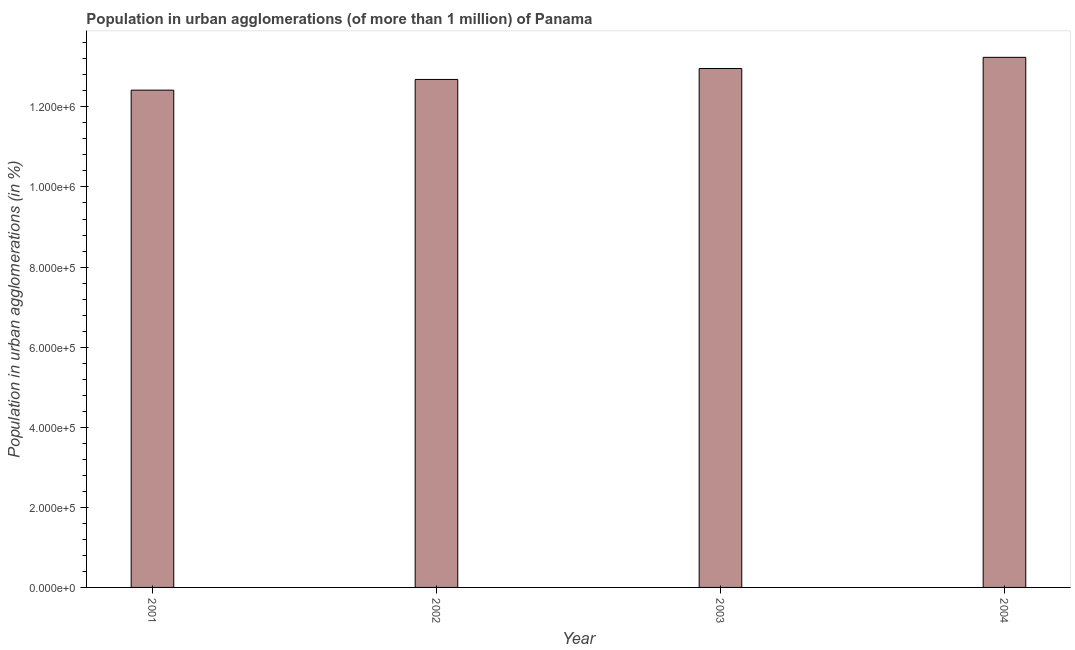What is the title of the graph?
Provide a succinct answer. Population in urban agglomerations (of more than 1 million) of Panama. What is the label or title of the Y-axis?
Keep it short and to the point. Population in urban agglomerations (in %). What is the population in urban agglomerations in 2003?
Provide a short and direct response. 1.30e+06. Across all years, what is the maximum population in urban agglomerations?
Your response must be concise. 1.32e+06. Across all years, what is the minimum population in urban agglomerations?
Provide a short and direct response. 1.24e+06. In which year was the population in urban agglomerations maximum?
Your answer should be very brief. 2004. What is the sum of the population in urban agglomerations?
Your response must be concise. 5.13e+06. What is the difference between the population in urban agglomerations in 2002 and 2004?
Offer a very short reply. -5.52e+04. What is the average population in urban agglomerations per year?
Provide a short and direct response. 1.28e+06. What is the median population in urban agglomerations?
Offer a very short reply. 1.28e+06. In how many years, is the population in urban agglomerations greater than 1120000 %?
Your response must be concise. 4. Do a majority of the years between 2002 and 2003 (inclusive) have population in urban agglomerations greater than 480000 %?
Ensure brevity in your answer.  Yes. What is the ratio of the population in urban agglomerations in 2002 to that in 2004?
Give a very brief answer. 0.96. Is the population in urban agglomerations in 2001 less than that in 2003?
Give a very brief answer. Yes. What is the difference between the highest and the second highest population in urban agglomerations?
Your answer should be very brief. 2.79e+04. What is the difference between the highest and the lowest population in urban agglomerations?
Offer a very short reply. 8.20e+04. Are all the bars in the graph horizontal?
Offer a very short reply. No. How many years are there in the graph?
Your answer should be compact. 4. Are the values on the major ticks of Y-axis written in scientific E-notation?
Your answer should be compact. Yes. What is the Population in urban agglomerations (in %) of 2001?
Ensure brevity in your answer.  1.24e+06. What is the Population in urban agglomerations (in %) in 2002?
Your response must be concise. 1.27e+06. What is the Population in urban agglomerations (in %) of 2003?
Ensure brevity in your answer.  1.30e+06. What is the Population in urban agglomerations (in %) of 2004?
Keep it short and to the point. 1.32e+06. What is the difference between the Population in urban agglomerations (in %) in 2001 and 2002?
Offer a terse response. -2.67e+04. What is the difference between the Population in urban agglomerations (in %) in 2001 and 2003?
Make the answer very short. -5.40e+04. What is the difference between the Population in urban agglomerations (in %) in 2001 and 2004?
Ensure brevity in your answer.  -8.20e+04. What is the difference between the Population in urban agglomerations (in %) in 2002 and 2003?
Keep it short and to the point. -2.73e+04. What is the difference between the Population in urban agglomerations (in %) in 2002 and 2004?
Offer a very short reply. -5.52e+04. What is the difference between the Population in urban agglomerations (in %) in 2003 and 2004?
Your answer should be compact. -2.79e+04. What is the ratio of the Population in urban agglomerations (in %) in 2001 to that in 2003?
Make the answer very short. 0.96. What is the ratio of the Population in urban agglomerations (in %) in 2001 to that in 2004?
Offer a very short reply. 0.94. What is the ratio of the Population in urban agglomerations (in %) in 2002 to that in 2003?
Your answer should be very brief. 0.98. What is the ratio of the Population in urban agglomerations (in %) in 2002 to that in 2004?
Give a very brief answer. 0.96. 